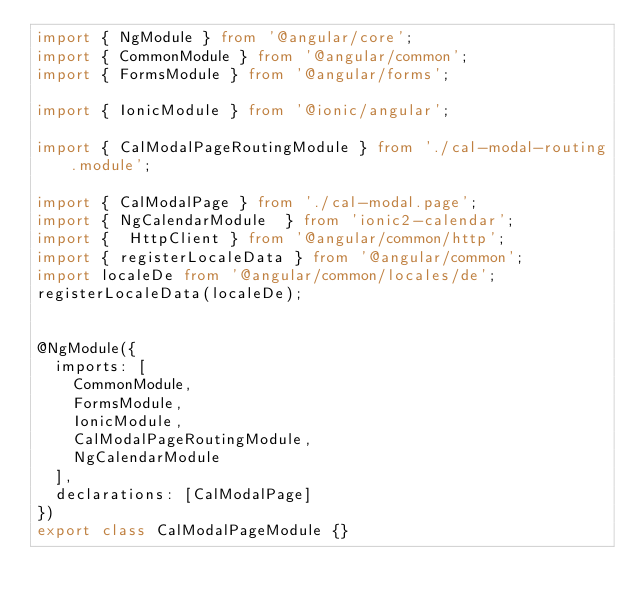<code> <loc_0><loc_0><loc_500><loc_500><_TypeScript_>import { NgModule } from '@angular/core';
import { CommonModule } from '@angular/common';
import { FormsModule } from '@angular/forms';

import { IonicModule } from '@ionic/angular';

import { CalModalPageRoutingModule } from './cal-modal-routing.module';

import { CalModalPage } from './cal-modal.page';
import { NgCalendarModule  } from 'ionic2-calendar';
import {  HttpClient } from '@angular/common/http';
import { registerLocaleData } from '@angular/common';
import localeDe from '@angular/common/locales/de';
registerLocaleData(localeDe);


@NgModule({
  imports: [
    CommonModule,
    FormsModule,
    IonicModule,
    CalModalPageRoutingModule,
    NgCalendarModule
  ],
  declarations: [CalModalPage]
})
export class CalModalPageModule {}
</code> 